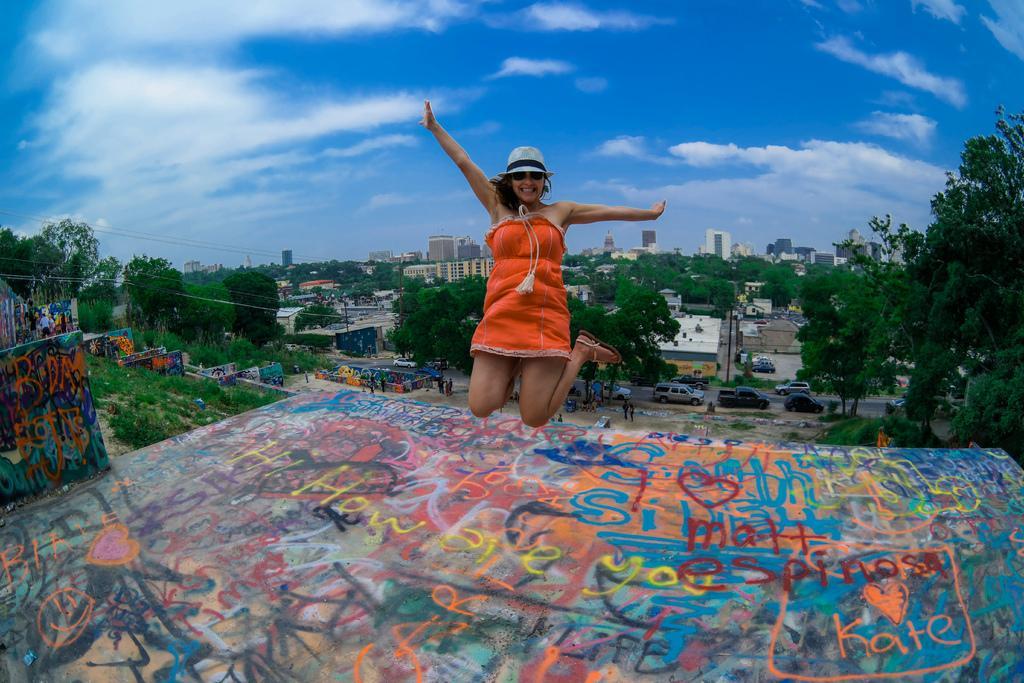Describe this image in one or two sentences. In this image we can see a woman wearing the cap and smiling and also jumping. We can also see the graffiti surface and also the graffiti wall. In the background we can see many trees, buildings and also the vehicles on the road. We can also see some people. There is sky with the clouds. We can also see the electrical wires and also the pole. 